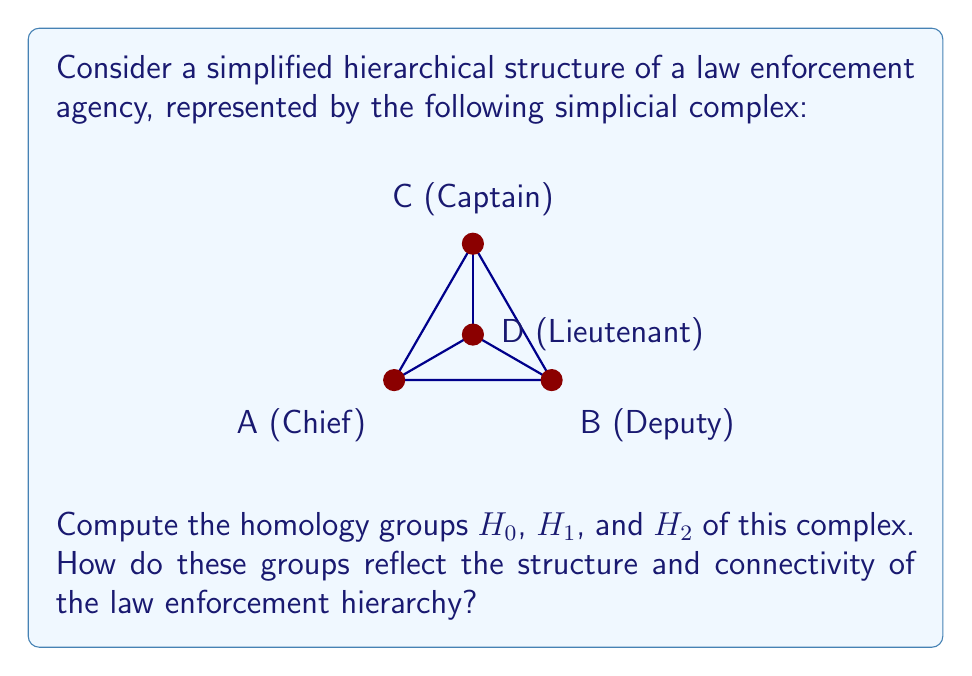Help me with this question. Let's approach this step-by-step:

1) First, we need to identify the simplices in each dimension:
   0-simplices: $\{A, B, C, D\}$
   1-simplices: $\{AB, BC, CA, AD, BD, CD\}$
   2-simplices: $\{ABC\}$

2) Now, let's calculate the chain groups:
   $C_0 = \mathbb{Z}^4$ (4 vertices)
   $C_1 = \mathbb{Z}^6$ (6 edges)
   $C_2 = \mathbb{Z}^1$ (1 triangle)
   $C_n = 0$ for $n \geq 3$

3) Next, we need to compute the boundary maps:
   $\partial_2: C_2 \to C_1$
   $\partial_1: C_1 \to C_0$

4) The ranks of these boundary maps are:
   $rank(\partial_2) = 1$
   $rank(\partial_1) = 3$

5) Now we can calculate the homology groups:
   
   $H_0 = ker(\partial_0) / im(\partial_1)$
   $dim(H_0) = dim(ker(\partial_0)) - rank(\partial_1) = 4 - 3 = 1$
   
   $H_1 = ker(\partial_1) / im(\partial_2)$
   $dim(H_1) = dim(ker(\partial_1)) - rank(\partial_2) = 3 - 1 = 2$
   
   $H_2 = ker(\partial_2) / im(\partial_3) = ker(\partial_2) = 0$

6) Therefore:
   $H_0 \cong \mathbb{Z}$
   $H_1 \cong \mathbb{Z} \oplus \mathbb{Z}$
   $H_2 = 0$

Interpretation:
- $H_0 \cong \mathbb{Z}$ indicates that the complex is connected, representing a unified command structure.
- $H_1 \cong \mathbb{Z} \oplus \mathbb{Z}$ shows two independent cycles in the structure, possibly representing two different chains of command or reporting lines.
- $H_2 = 0$ indicates no enclosed voids, suggesting a transparent hierarchy without hidden power structures.
Answer: $H_0 \cong \mathbb{Z}$, $H_1 \cong \mathbb{Z} \oplus \mathbb{Z}$, $H_2 = 0$ 